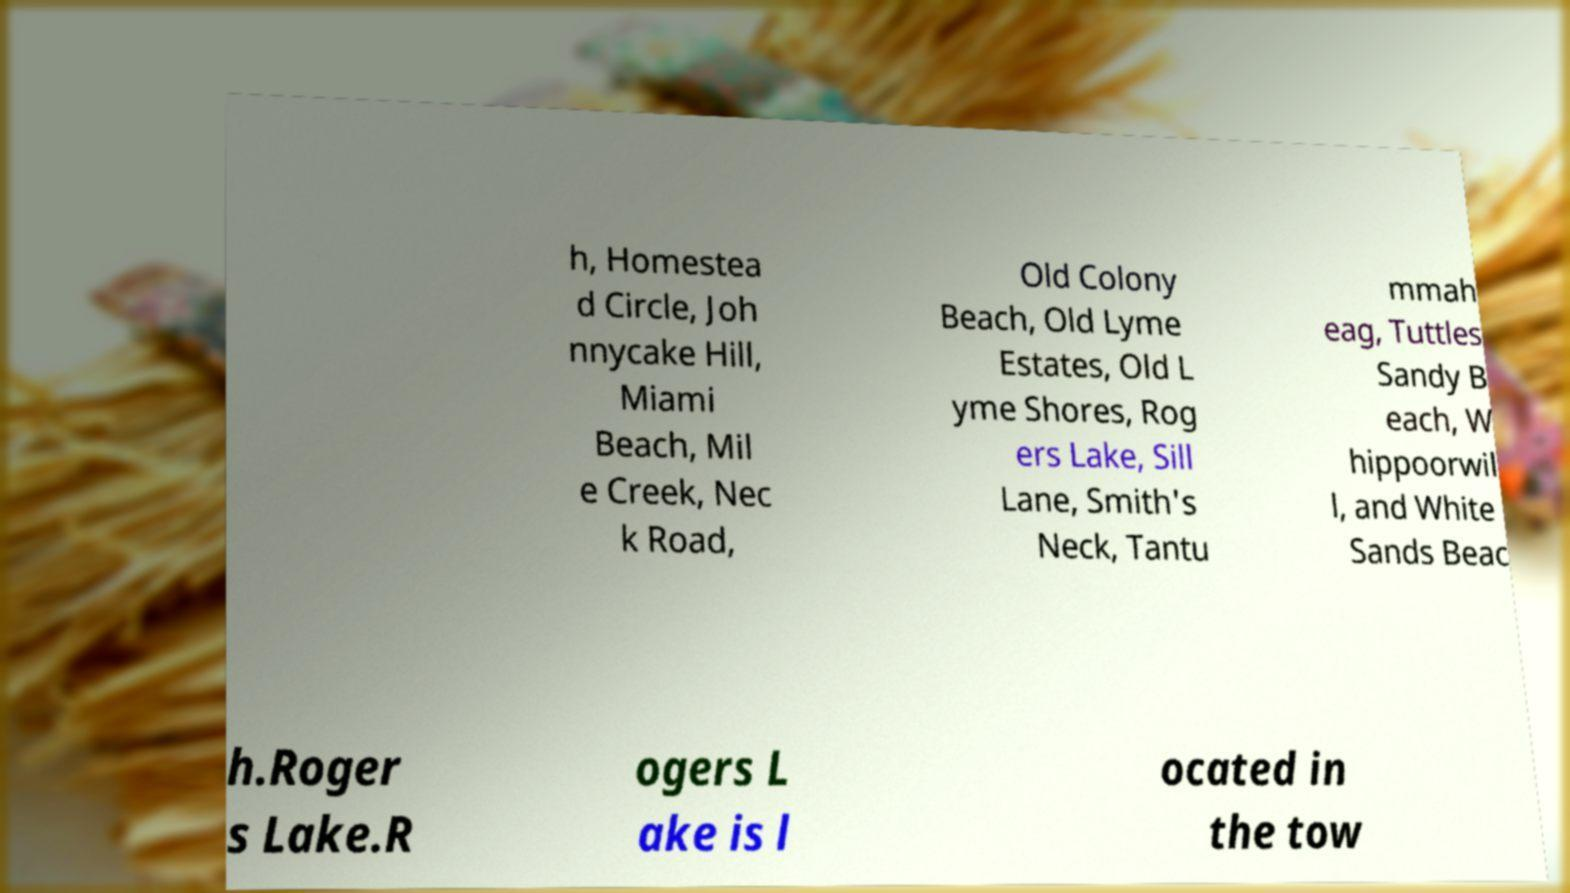For documentation purposes, I need the text within this image transcribed. Could you provide that? h, Homestea d Circle, Joh nnycake Hill, Miami Beach, Mil e Creek, Nec k Road, Old Colony Beach, Old Lyme Estates, Old L yme Shores, Rog ers Lake, Sill Lane, Smith's Neck, Tantu mmah eag, Tuttles Sandy B each, W hippoorwil l, and White Sands Beac h.Roger s Lake.R ogers L ake is l ocated in the tow 